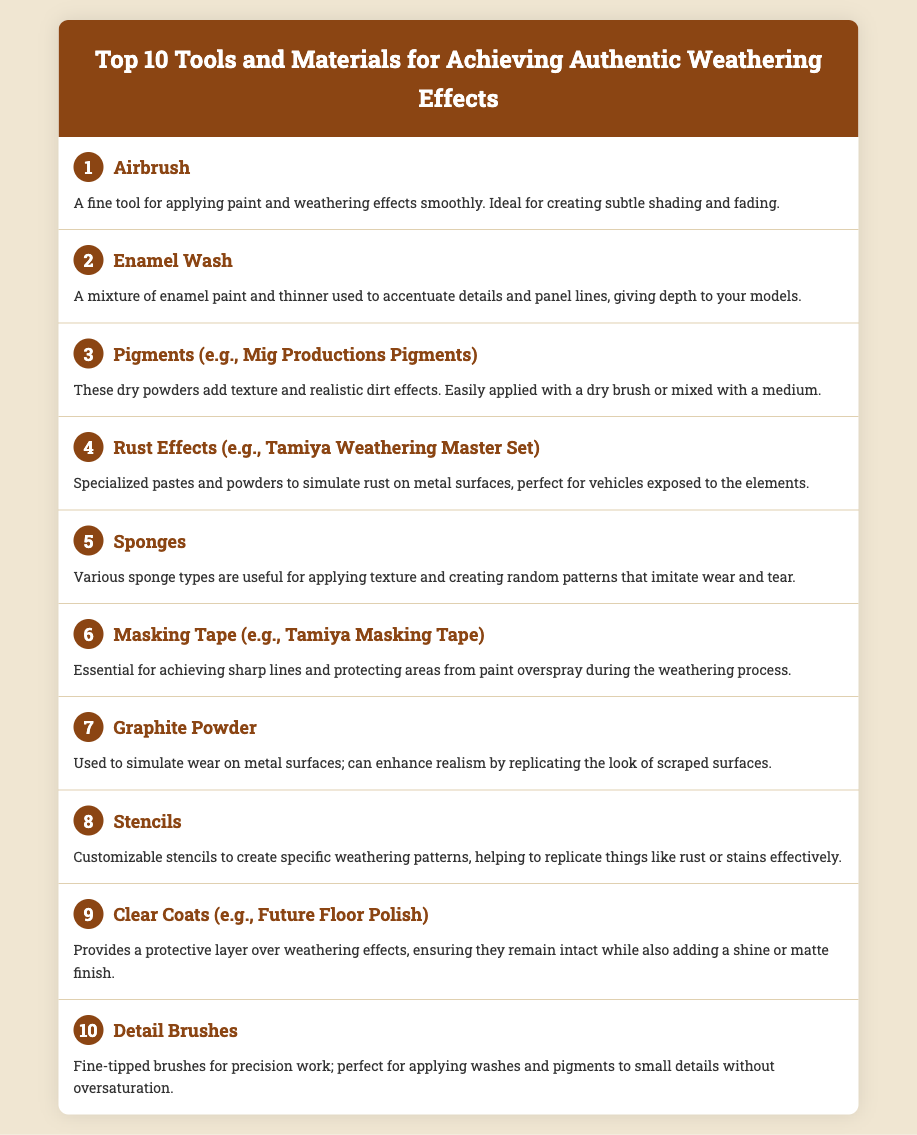What is the first tool listed? The first tool in the menu is "Airbrush."
Answer: Airbrush How many tools are listed in the document? The document features a total of ten tools for weathering effects.
Answer: 10 What type of paint is combined with thinner in the second item? The second item mentions a mixture of "enamel paint" and thinner used for washes.
Answer: Enamel paint Which item is specifically mentioned for creating random patterns? The fifth item describes "Sponges" as useful for applying texture and creating random patterns.
Answer: Sponges What number is associated with the "Clear Coats"? "Clear Coats" is the ninth tool mentioned in the list.
Answer: 9 Which tool is essential for achieving sharp lines during the weathering process? The sixth item mentions "Masking Tape" as essential for sharp lines and protecting areas.
Answer: Masking Tape What material is used to simulate wear on metal surfaces? The seventh tool listed is "Graphite Powder," used for simulating wear.
Answer: Graphite Powder What is the purpose of "Detail Brushes" as per the last item? The last item explains that "Detail Brushes" are for precision work, particularly to avoid oversaturation.
Answer: Precision work 